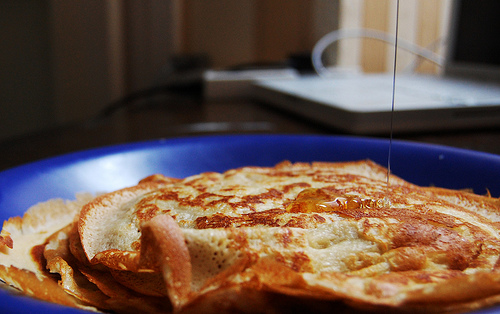<image>
Is the laptop on the pancake? No. The laptop is not positioned on the pancake. They may be near each other, but the laptop is not supported by or resting on top of the pancake. 